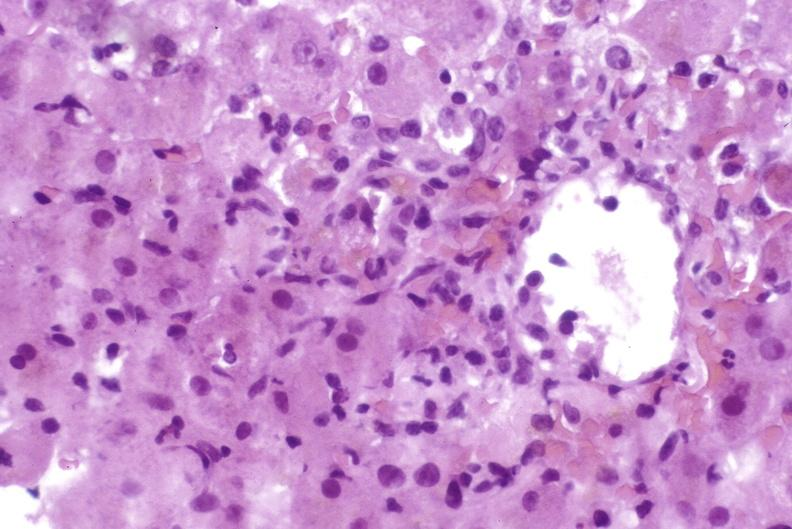does malignant thymoma show moderate acute rejection?
Answer the question using a single word or phrase. No 